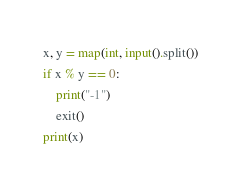Convert code to text. <code><loc_0><loc_0><loc_500><loc_500><_Python_>x, y = map(int, input().split())
if x % y == 0:
    print("-1")
    exit()
print(x)</code> 